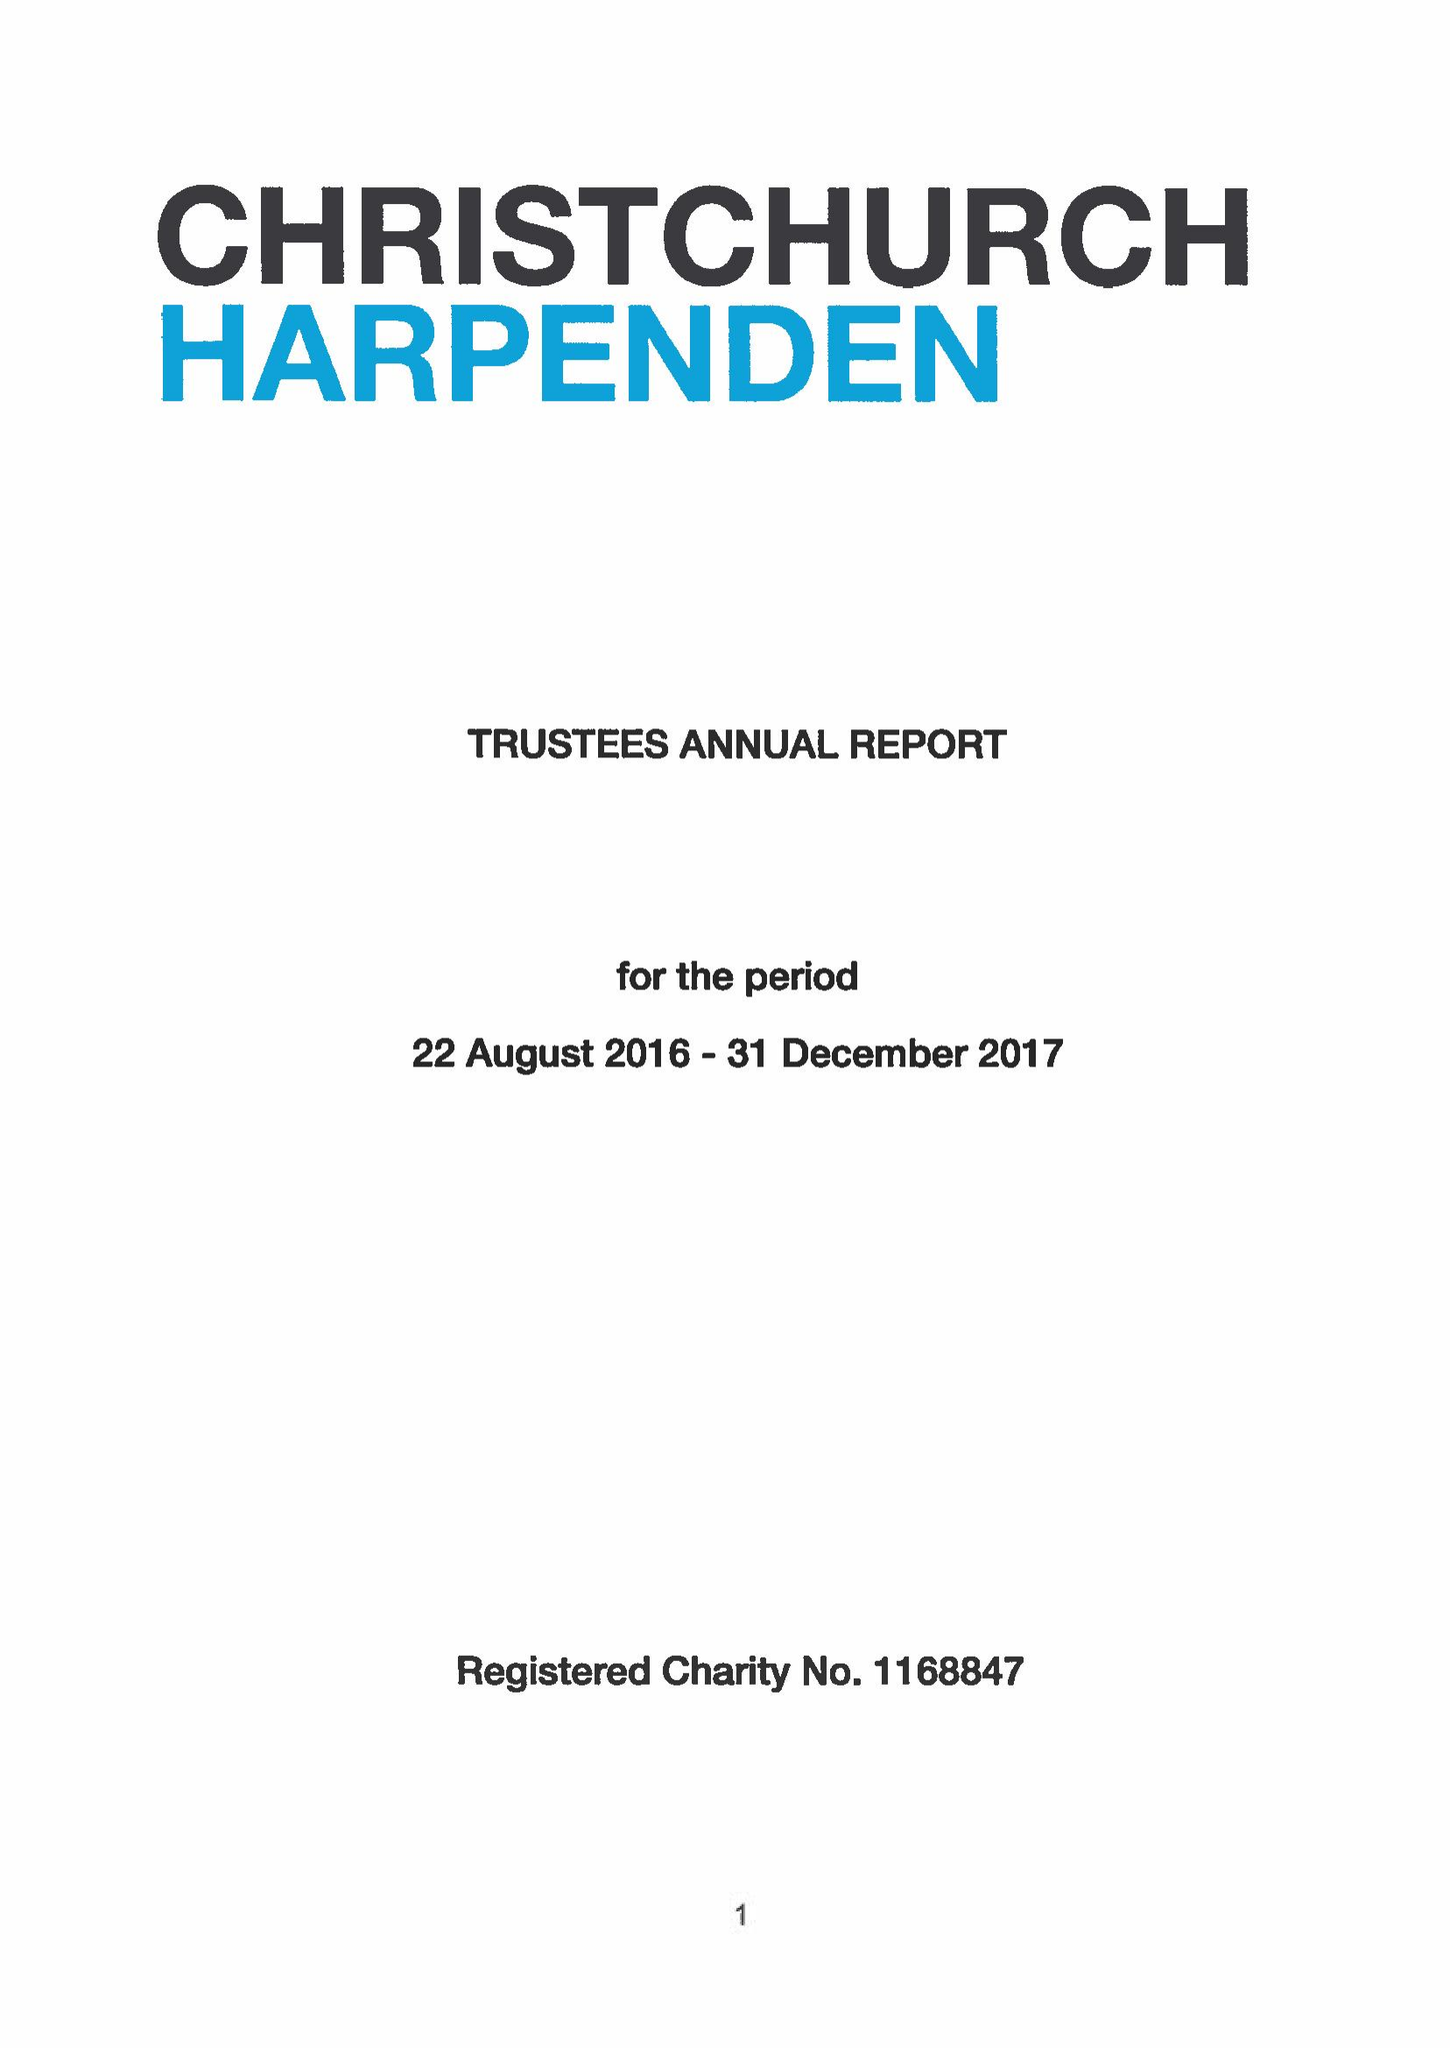What is the value for the report_date?
Answer the question using a single word or phrase. 2017-12-31 